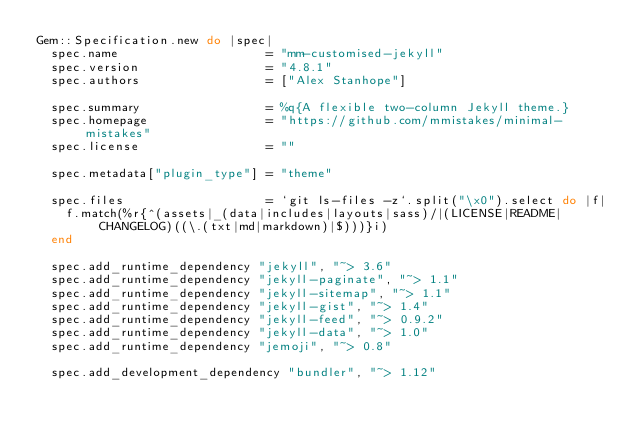<code> <loc_0><loc_0><loc_500><loc_500><_Ruby_>Gem::Specification.new do |spec|
  spec.name                    = "mm-customised-jekyll"
  spec.version                 = "4.8.1"
  spec.authors                 = ["Alex Stanhope"]

  spec.summary                 = %q{A flexible two-column Jekyll theme.}
  spec.homepage                = "https://github.com/mmistakes/minimal-mistakes"
  spec.license                 = ""

  spec.metadata["plugin_type"] = "theme"

  spec.files                   = `git ls-files -z`.split("\x0").select do |f|
    f.match(%r{^(assets|_(data|includes|layouts|sass)/|(LICENSE|README|CHANGELOG)((\.(txt|md|markdown)|$)))}i)
  end

  spec.add_runtime_dependency "jekyll", "~> 3.6"
  spec.add_runtime_dependency "jekyll-paginate", "~> 1.1"
  spec.add_runtime_dependency "jekyll-sitemap", "~> 1.1"
  spec.add_runtime_dependency "jekyll-gist", "~> 1.4"
  spec.add_runtime_dependency "jekyll-feed", "~> 0.9.2"
  spec.add_runtime_dependency "jekyll-data", "~> 1.0"
  spec.add_runtime_dependency "jemoji", "~> 0.8"

  spec.add_development_dependency "bundler", "~> 1.12"</code> 